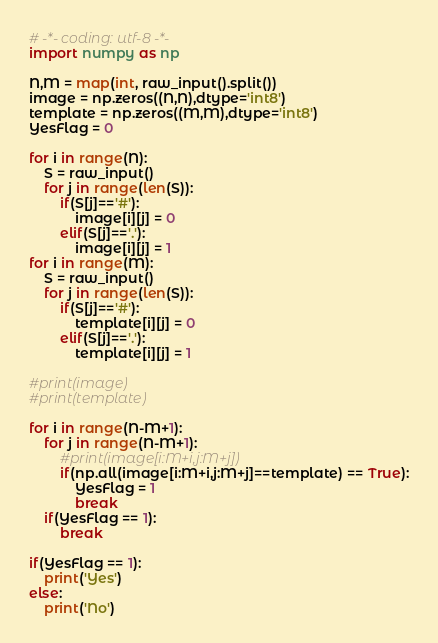Convert code to text. <code><loc_0><loc_0><loc_500><loc_500><_Python_># -*- coding: utf-8 -*-
import numpy as np

N,M = map(int, raw_input().split())
image = np.zeros((N,N),dtype='int8')
template = np.zeros((M,M),dtype='int8')
YesFlag = 0

for i in range(N):
    S = raw_input()
    for j in range(len(S)):
        if(S[j]=='#'):
            image[i][j] = 0
        elif(S[j]=='.'):
            image[i][j] = 1
for i in range(M):
    S = raw_input()
    for j in range(len(S)):
        if(S[j]=='#'):
            template[i][j] = 0
        elif(S[j]=='.'):
            template[i][j] = 1

#print(image)
#print(template)

for i in range(N-M+1):
    for j in range(N-M+1):
        #print(image[i:M+i,j:M+j])
        if(np.all(image[i:M+i,j:M+j]==template) == True):
            YesFlag = 1
            break
    if(YesFlag == 1):
        break

if(YesFlag == 1):
    print('Yes')
else:
    print('No')</code> 